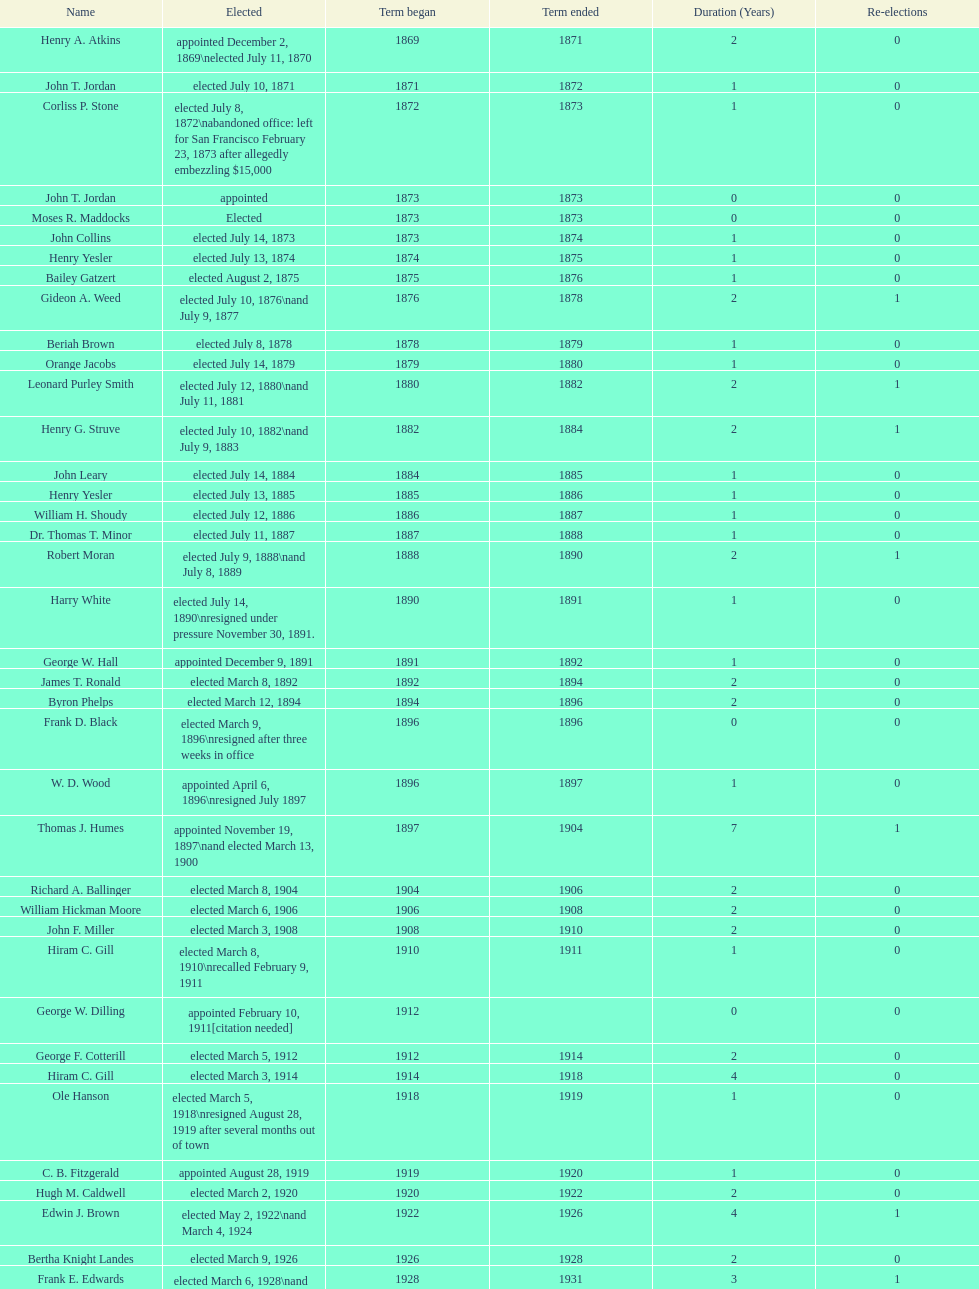Who was the mayor before jordan? Henry A. Atkins. 